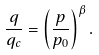Convert formula to latex. <formula><loc_0><loc_0><loc_500><loc_500>\frac { q } { q _ { c } } = \left ( \frac { p } { p _ { 0 } } \right ) ^ { \beta } .</formula> 